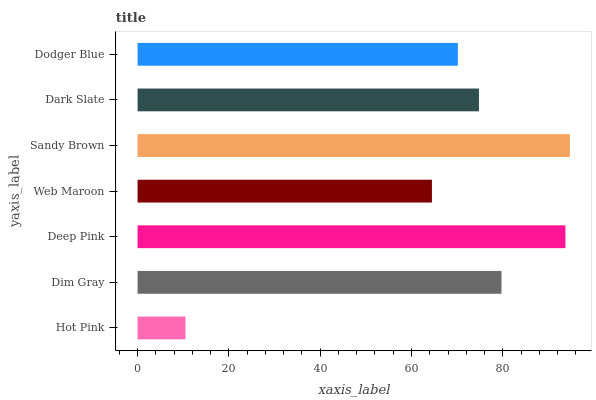Is Hot Pink the minimum?
Answer yes or no. Yes. Is Sandy Brown the maximum?
Answer yes or no. Yes. Is Dim Gray the minimum?
Answer yes or no. No. Is Dim Gray the maximum?
Answer yes or no. No. Is Dim Gray greater than Hot Pink?
Answer yes or no. Yes. Is Hot Pink less than Dim Gray?
Answer yes or no. Yes. Is Hot Pink greater than Dim Gray?
Answer yes or no. No. Is Dim Gray less than Hot Pink?
Answer yes or no. No. Is Dark Slate the high median?
Answer yes or no. Yes. Is Dark Slate the low median?
Answer yes or no. Yes. Is Sandy Brown the high median?
Answer yes or no. No. Is Dim Gray the low median?
Answer yes or no. No. 